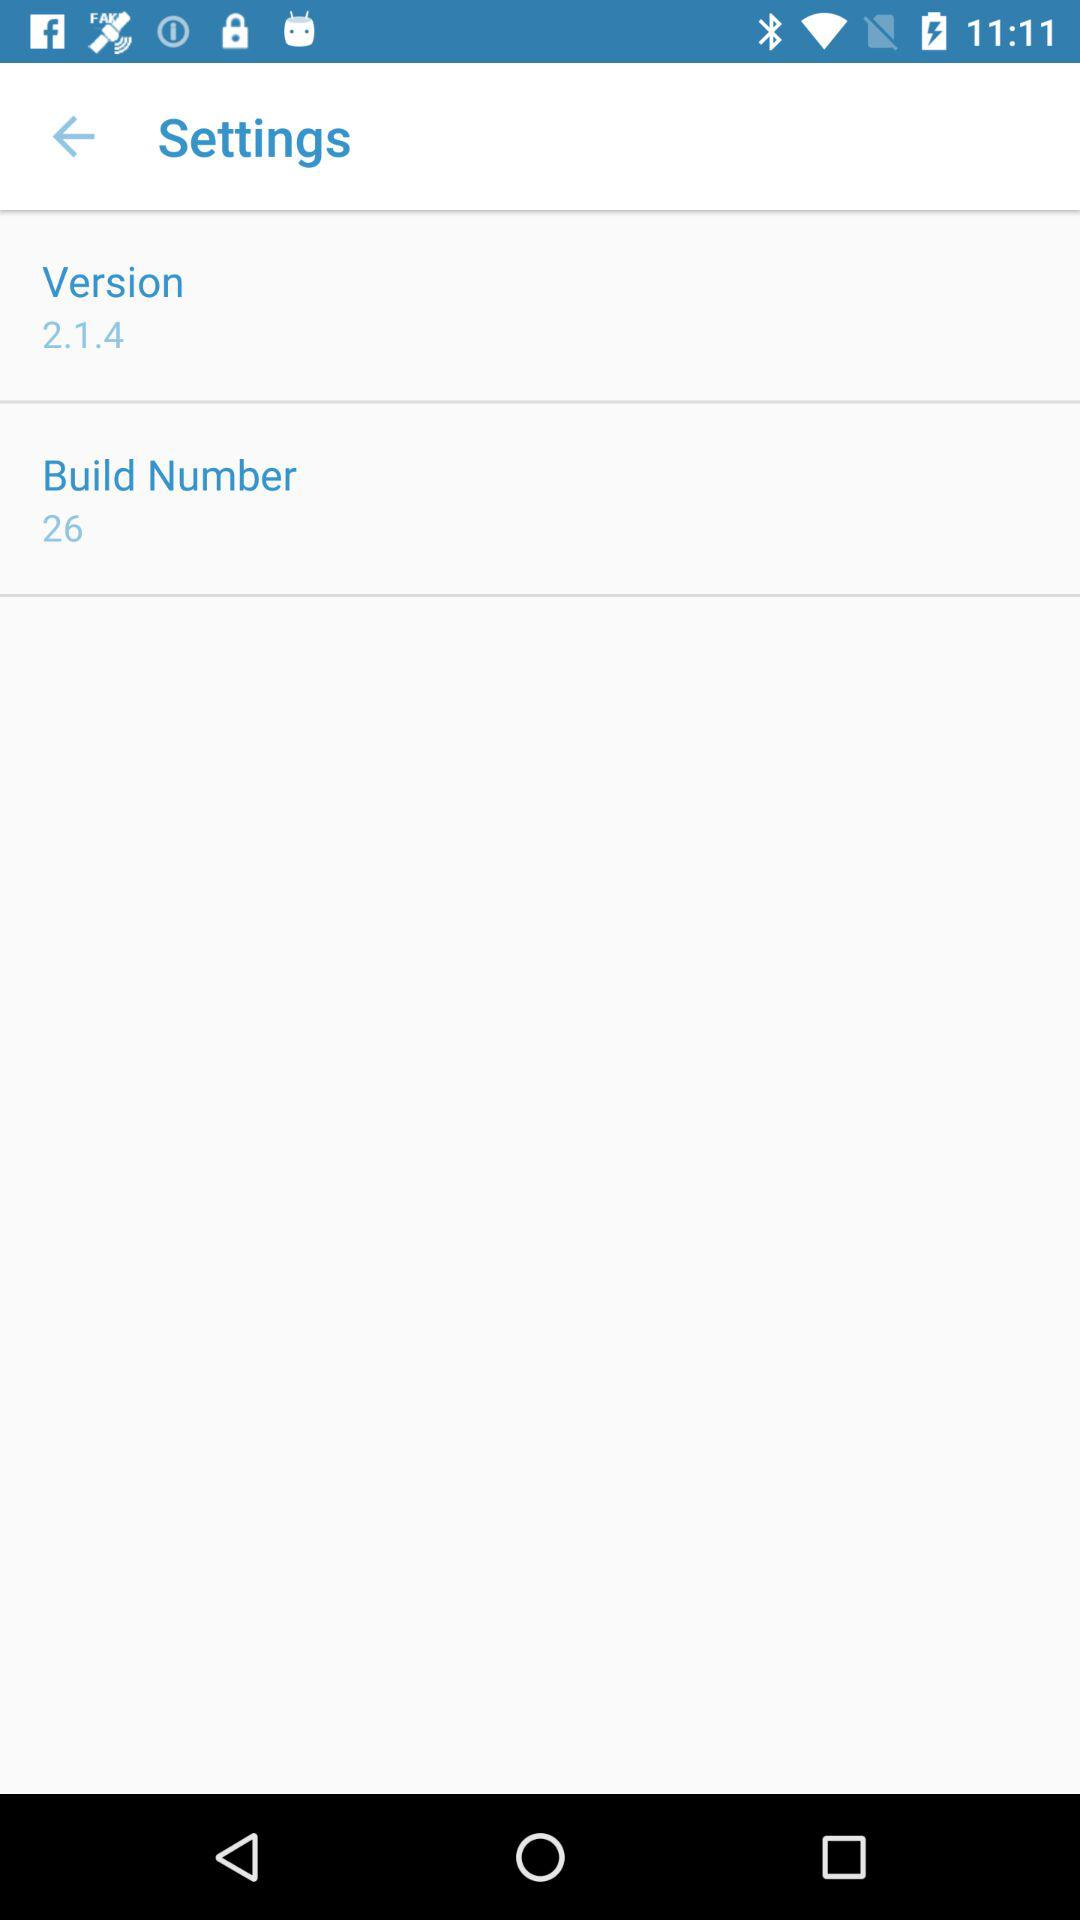What is the sum of the version number and the build number?
Answer the question using a single word or phrase. 28 